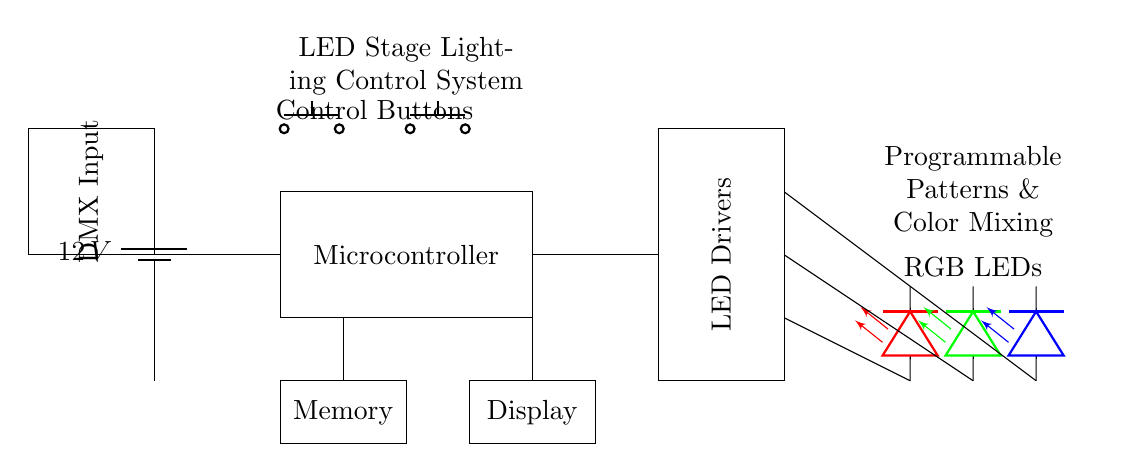What is the voltage rating of the power supply? The power supply in the circuit is represented by the battery symbol with a label stating "12 V," indicating that it provides a voltage of twelve volts.
Answer: 12 V What is the function of the microcontroller in this system? The microcontroller, shown as a rectangle in the circuit, is responsible for controlling the LED drivers. It processes input signals and sends out control commands to manage the LEDs, thus enabling programmable patterns and color mixing.
Answer: Control How many RGB LEDs are connected to the LED drivers? The circuit shows three separate LED symbols, each representing one of the primary colors for RGB: red, green, and blue. Therefore, there are three RGB LEDs connected to the drivers.
Answer: Three What is the purpose of the DMX input? The DMX input is indicated by a rectangle labeled "DMX Input," which allows for external control of the lighting system via the DMX protocol, typically used in stage and event lighting for complex control systems.
Answer: External control How many control buttons are included in this circuit? There are two push buttons located above the microcontroller, labeled as "Control Buttons." This indicates that the system has two buttons for user interaction or instruction to modify the lighting.
Answer: Two What is the role of the memory component in the control system? The memory component, represented in the circuit as a rectangle labeled "Memory," is used to store programmable settings and patterns that can be remembered and recalled for the LED lighting control. This is critical for maintaining specific lighting sequences.
Answer: Storage What type of control does this system provide for LED lights? The diagram specifies that the system is designed for "Programmable Patterns & Color Mixing," indicating that the control includes customizable sequences and color variations for the LEDs, tailored for dynamic performance settings.
Answer: Programmable 